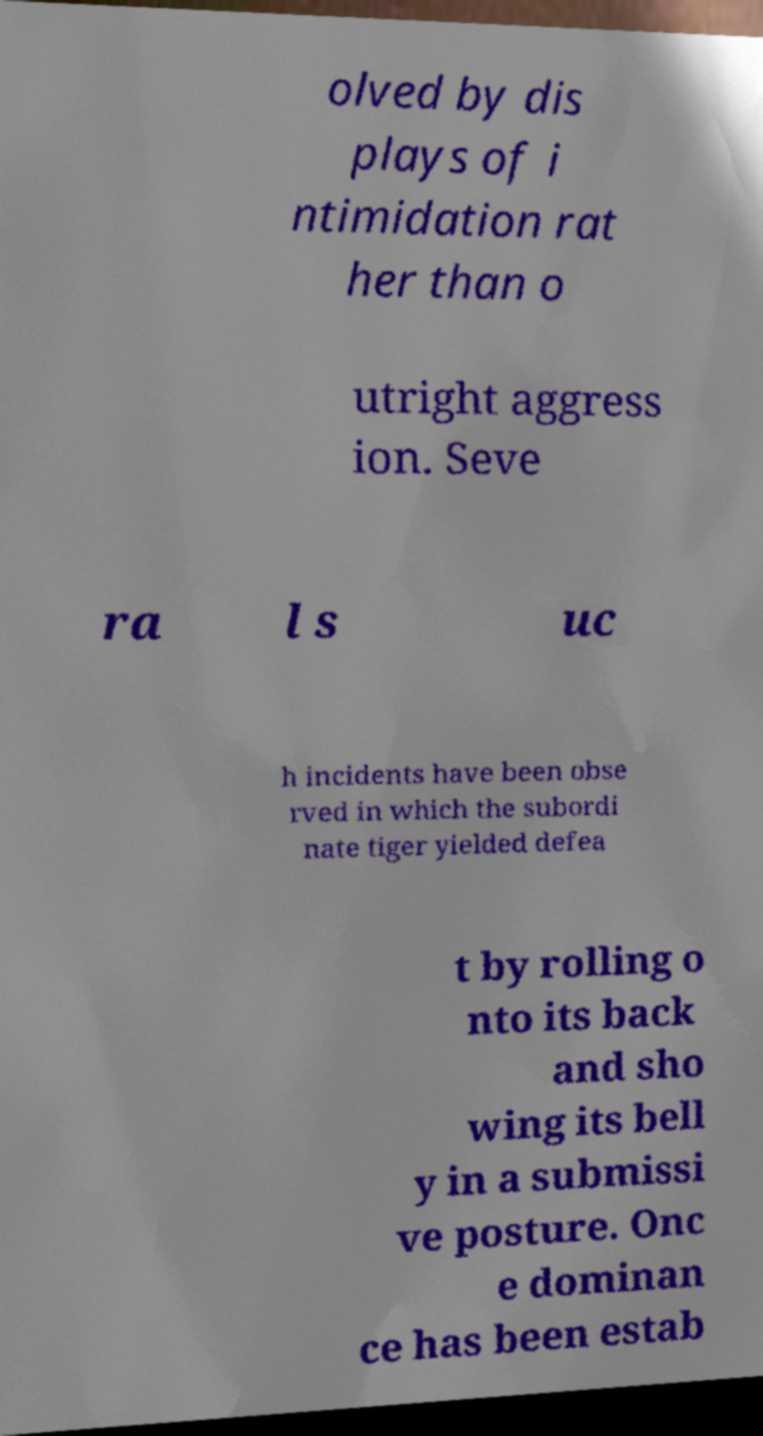Could you extract and type out the text from this image? olved by dis plays of i ntimidation rat her than o utright aggress ion. Seve ra l s uc h incidents have been obse rved in which the subordi nate tiger yielded defea t by rolling o nto its back and sho wing its bell y in a submissi ve posture. Onc e dominan ce has been estab 